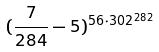<formula> <loc_0><loc_0><loc_500><loc_500>( \frac { 7 } { 2 8 4 } - 5 ) ^ { 5 6 \cdot 3 0 2 ^ { 2 8 2 } }</formula> 